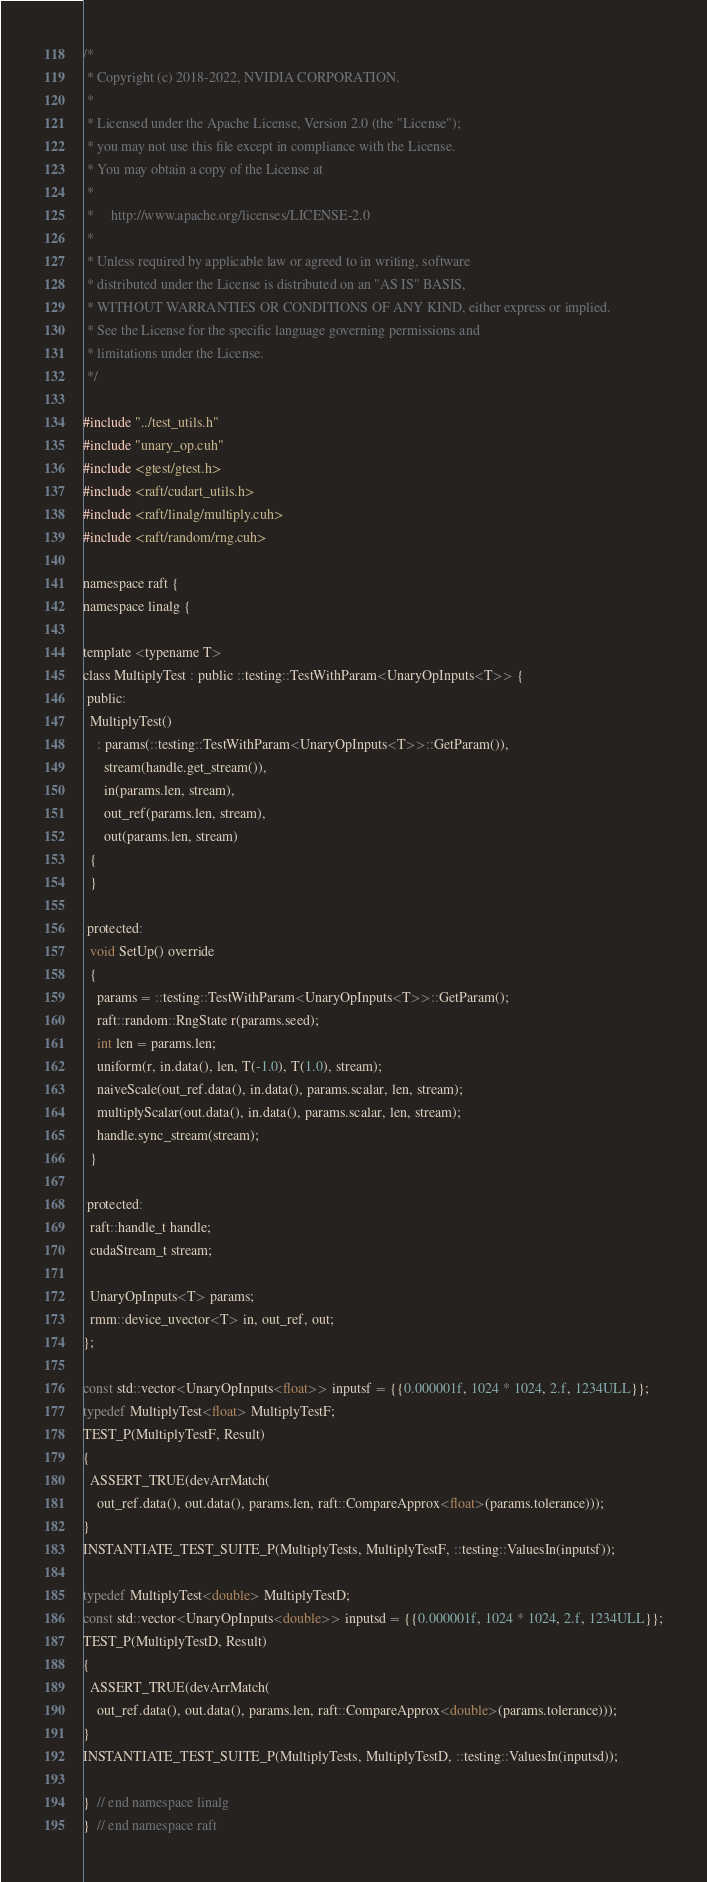<code> <loc_0><loc_0><loc_500><loc_500><_Cuda_>/*
 * Copyright (c) 2018-2022, NVIDIA CORPORATION.
 *
 * Licensed under the Apache License, Version 2.0 (the "License");
 * you may not use this file except in compliance with the License.
 * You may obtain a copy of the License at
 *
 *     http://www.apache.org/licenses/LICENSE-2.0
 *
 * Unless required by applicable law or agreed to in writing, software
 * distributed under the License is distributed on an "AS IS" BASIS,
 * WITHOUT WARRANTIES OR CONDITIONS OF ANY KIND, either express or implied.
 * See the License for the specific language governing permissions and
 * limitations under the License.
 */

#include "../test_utils.h"
#include "unary_op.cuh"
#include <gtest/gtest.h>
#include <raft/cudart_utils.h>
#include <raft/linalg/multiply.cuh>
#include <raft/random/rng.cuh>

namespace raft {
namespace linalg {

template <typename T>
class MultiplyTest : public ::testing::TestWithParam<UnaryOpInputs<T>> {
 public:
  MultiplyTest()
    : params(::testing::TestWithParam<UnaryOpInputs<T>>::GetParam()),
      stream(handle.get_stream()),
      in(params.len, stream),
      out_ref(params.len, stream),
      out(params.len, stream)
  {
  }

 protected:
  void SetUp() override
  {
    params = ::testing::TestWithParam<UnaryOpInputs<T>>::GetParam();
    raft::random::RngState r(params.seed);
    int len = params.len;
    uniform(r, in.data(), len, T(-1.0), T(1.0), stream);
    naiveScale(out_ref.data(), in.data(), params.scalar, len, stream);
    multiplyScalar(out.data(), in.data(), params.scalar, len, stream);
    handle.sync_stream(stream);
  }

 protected:
  raft::handle_t handle;
  cudaStream_t stream;

  UnaryOpInputs<T> params;
  rmm::device_uvector<T> in, out_ref, out;
};

const std::vector<UnaryOpInputs<float>> inputsf = {{0.000001f, 1024 * 1024, 2.f, 1234ULL}};
typedef MultiplyTest<float> MultiplyTestF;
TEST_P(MultiplyTestF, Result)
{
  ASSERT_TRUE(devArrMatch(
    out_ref.data(), out.data(), params.len, raft::CompareApprox<float>(params.tolerance)));
}
INSTANTIATE_TEST_SUITE_P(MultiplyTests, MultiplyTestF, ::testing::ValuesIn(inputsf));

typedef MultiplyTest<double> MultiplyTestD;
const std::vector<UnaryOpInputs<double>> inputsd = {{0.000001f, 1024 * 1024, 2.f, 1234ULL}};
TEST_P(MultiplyTestD, Result)
{
  ASSERT_TRUE(devArrMatch(
    out_ref.data(), out.data(), params.len, raft::CompareApprox<double>(params.tolerance)));
}
INSTANTIATE_TEST_SUITE_P(MultiplyTests, MultiplyTestD, ::testing::ValuesIn(inputsd));

}  // end namespace linalg
}  // end namespace raft
</code> 